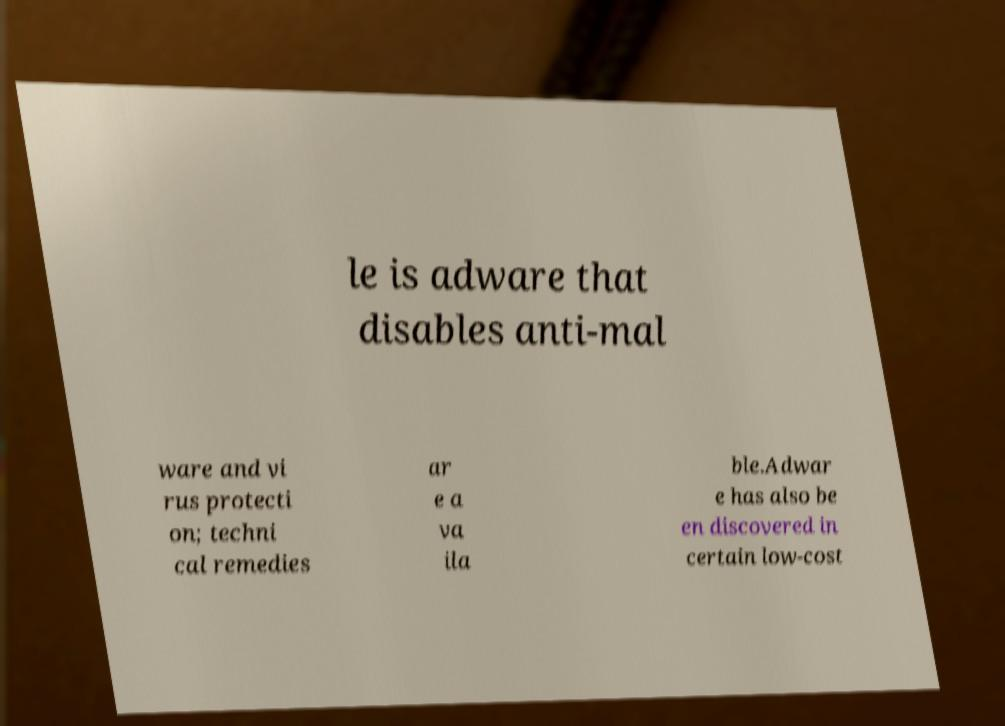Please identify and transcribe the text found in this image. le is adware that disables anti-mal ware and vi rus protecti on; techni cal remedies ar e a va ila ble.Adwar e has also be en discovered in certain low-cost 